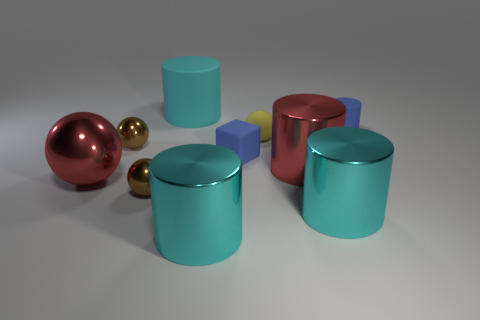Do the blue object that is behind the yellow matte object and the red thing to the left of the tiny rubber ball have the same material?
Your answer should be compact. No. Are there an equal number of big cyan metal things that are on the right side of the red sphere and spheres to the left of the small yellow rubber thing?
Provide a succinct answer. No. How many brown spheres are made of the same material as the tiny blue cylinder?
Make the answer very short. 0. There is a tiny rubber thing that is the same color as the rubber cube; what shape is it?
Offer a very short reply. Cylinder. There is a blue rubber object behind the brown metal sphere that is behind the large sphere; what is its size?
Ensure brevity in your answer.  Small. There is a tiny metallic thing in front of the tiny block; is it the same shape as the tiny blue thing that is on the left side of the small blue cylinder?
Provide a succinct answer. No. Is the number of matte cylinders on the left side of the small blue matte cylinder the same as the number of cyan rubber things?
Offer a very short reply. Yes. What is the color of the other big shiny thing that is the same shape as the yellow thing?
Your answer should be compact. Red. Does the big cyan object behind the tiny cylinder have the same material as the large red cylinder?
Provide a succinct answer. No. What number of big things are either blue matte objects or red metal things?
Provide a short and direct response. 2. 